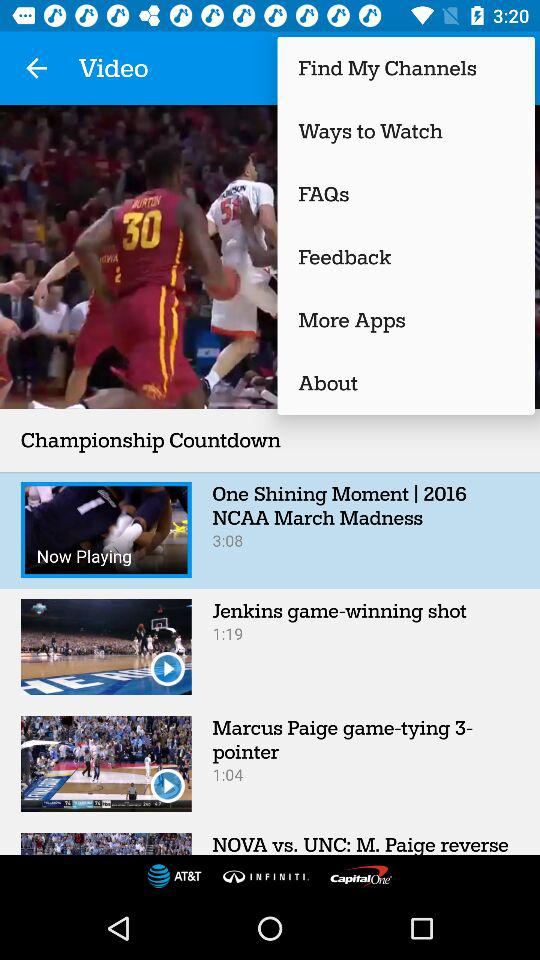What is the time duration of the video "Jenkins game-winning shot"? The time duration of the video "Jenkins game-winning shot" is 1 minute 19 seconds. 